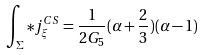Convert formula to latex. <formula><loc_0><loc_0><loc_500><loc_500>\int _ { \Sigma } * j _ { \xi } ^ { C S } = \frac { 1 } { 2 G _ { 5 } } ( \alpha + \frac { 2 } { 3 } ) ( \alpha - 1 )</formula> 